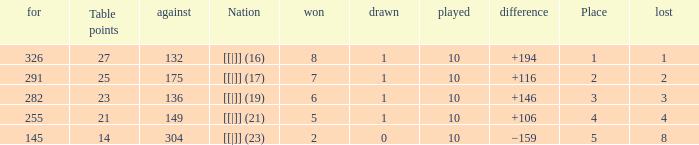 How many games had a deficit of 175?  1.0. 